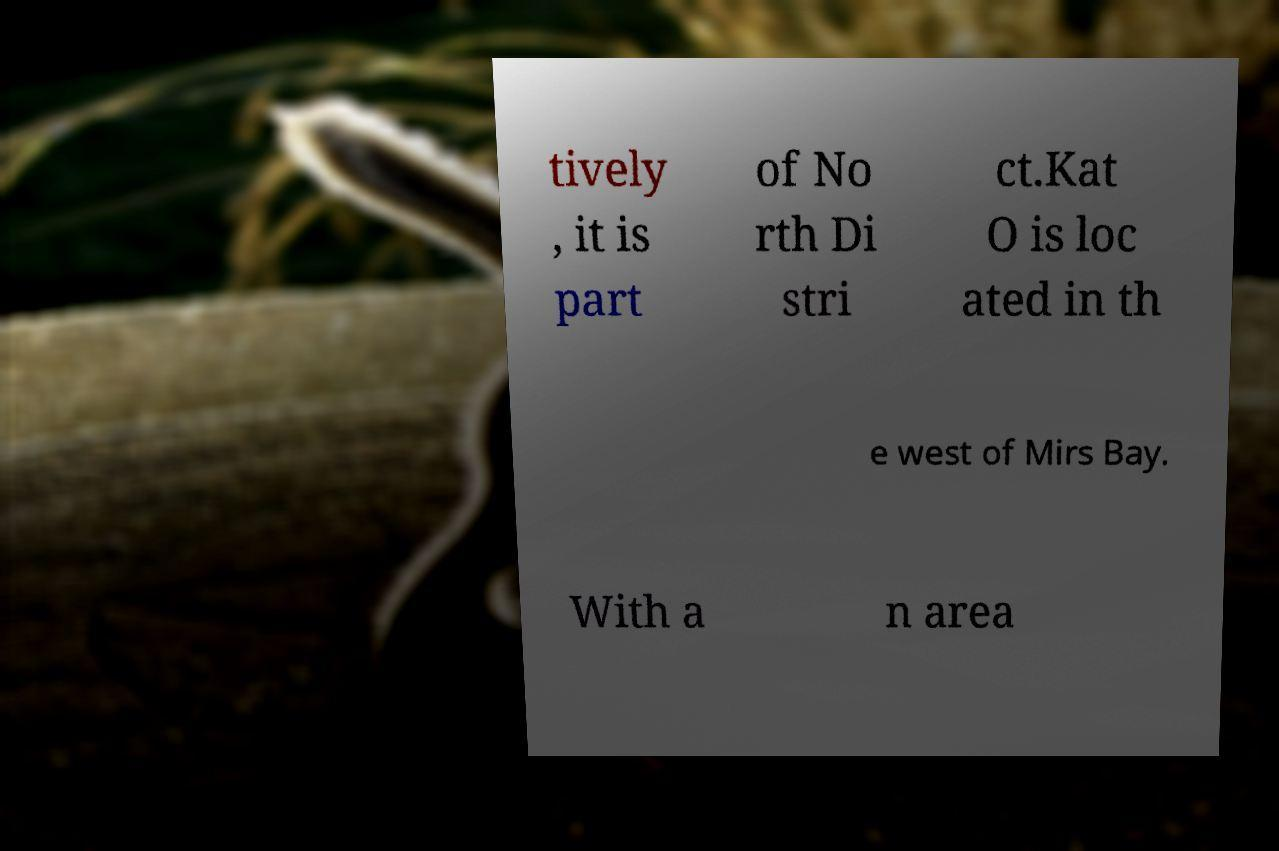Can you read and provide the text displayed in the image?This photo seems to have some interesting text. Can you extract and type it out for me? tively , it is part of No rth Di stri ct.Kat O is loc ated in th e west of Mirs Bay. With a n area 